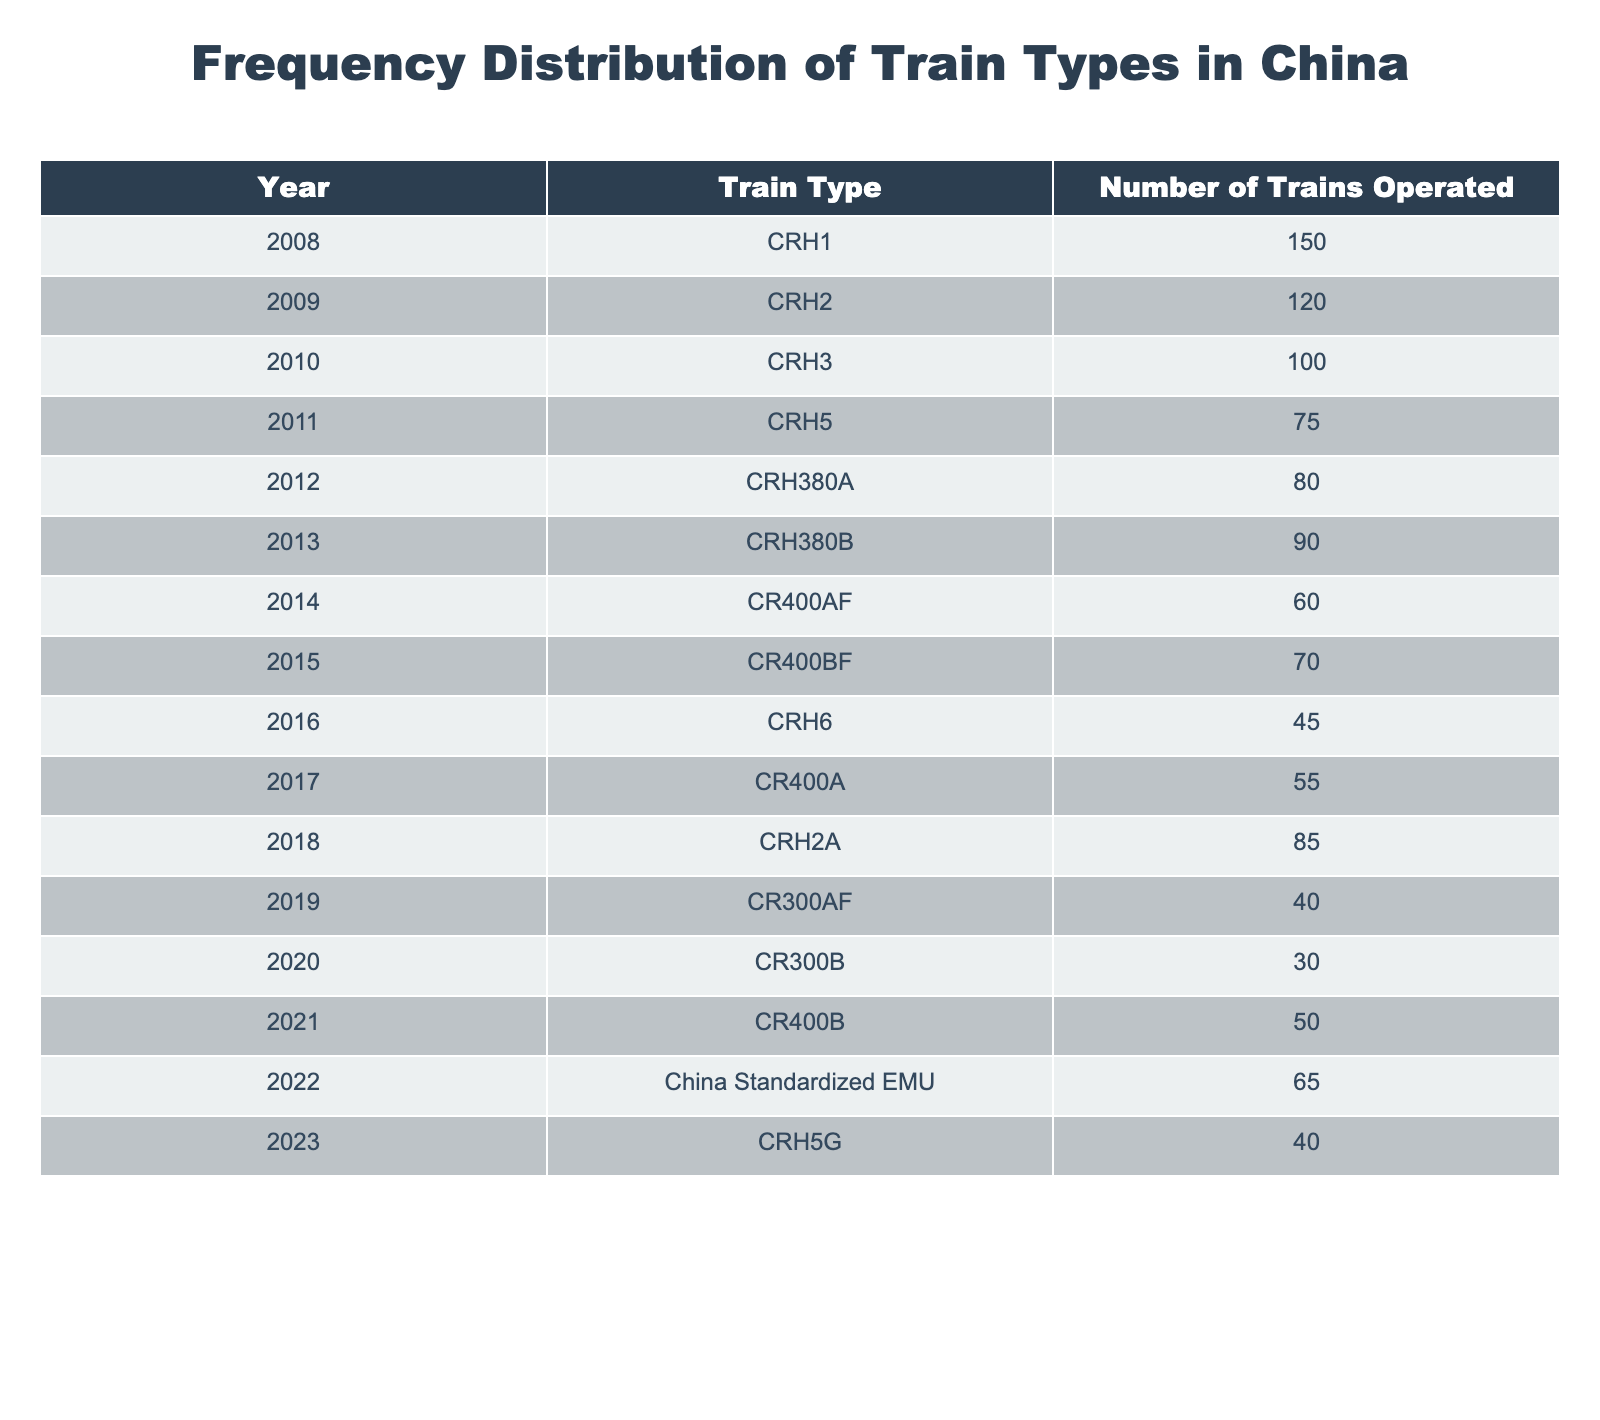What was the number of CRH1 trains operated in 2008? The table lists the number of CRH1 trains operated in 2008, which is directly given as 150.
Answer: 150 How many CRH trains were operated in total from 2008 to 2014? By summing the number of CRH trains from the years specified in the table: CRH1 (150) + CRH2 (120) + CRH3 (100) + CRH5 (75) + CRH380A (80) + CRH380B (90) + CR400AF (60) = 675.
Answer: 675 Was the number of trains operated in 2020 higher than in 2019? The number of trains operated in 2020 (30) is less than in 2019 (40), so the statement is false.
Answer: No Which year had the highest number of operated trains? By reviewing the table, 2008 had the highest number of trains operated, with 150.
Answer: 2008 What is the average number of trains operated per year from 2011 to 2023? The number of operated trains from 2011 to 2023 is: 75 (2011) + 80 (2012) + 90 (2013) + 60 (2014) + 70 (2015) + 45 (2016) + 55 (2017) + 85 (2018) + 40 (2019) + 30 (2020) + 50 (2021) + 65 (2022) + 40 (2023) = 725. There are 13 data points, so 725 divided by 13 gives an average of approximately 55.38.
Answer: 55.38 Have more CRH trains than CR400 trains been operated between 2014 and 2022? From 2014 to 2022, the trains are CR400AF (60), CR400BF (70), CR400A (55), and CR400B (50) for a total of 235 CR400 trains. For CRH types: CRH5 (75), CRH380A (80), CRH380B (90), CRH6 (45), CRH2A (85), and China Standardized EMU (65) for a total of 435 CRH trains. Since 435 > 235, the statement is true.
Answer: Yes What is the difference in the number of trains operated between 2008 and 2023? The number of trains in 2008 is 150 and in 2023 is 40. The difference is 150 - 40 = 110.
Answer: 110 In which year did the number of CRH trains dropped the most compared to the previous year? By analyzing the annual changes, the biggest drop happened from 2016 (45) to 2017 (55), where the total dropped by 10 trains compared to the previous year's 70.
Answer: 2016 to 2017 